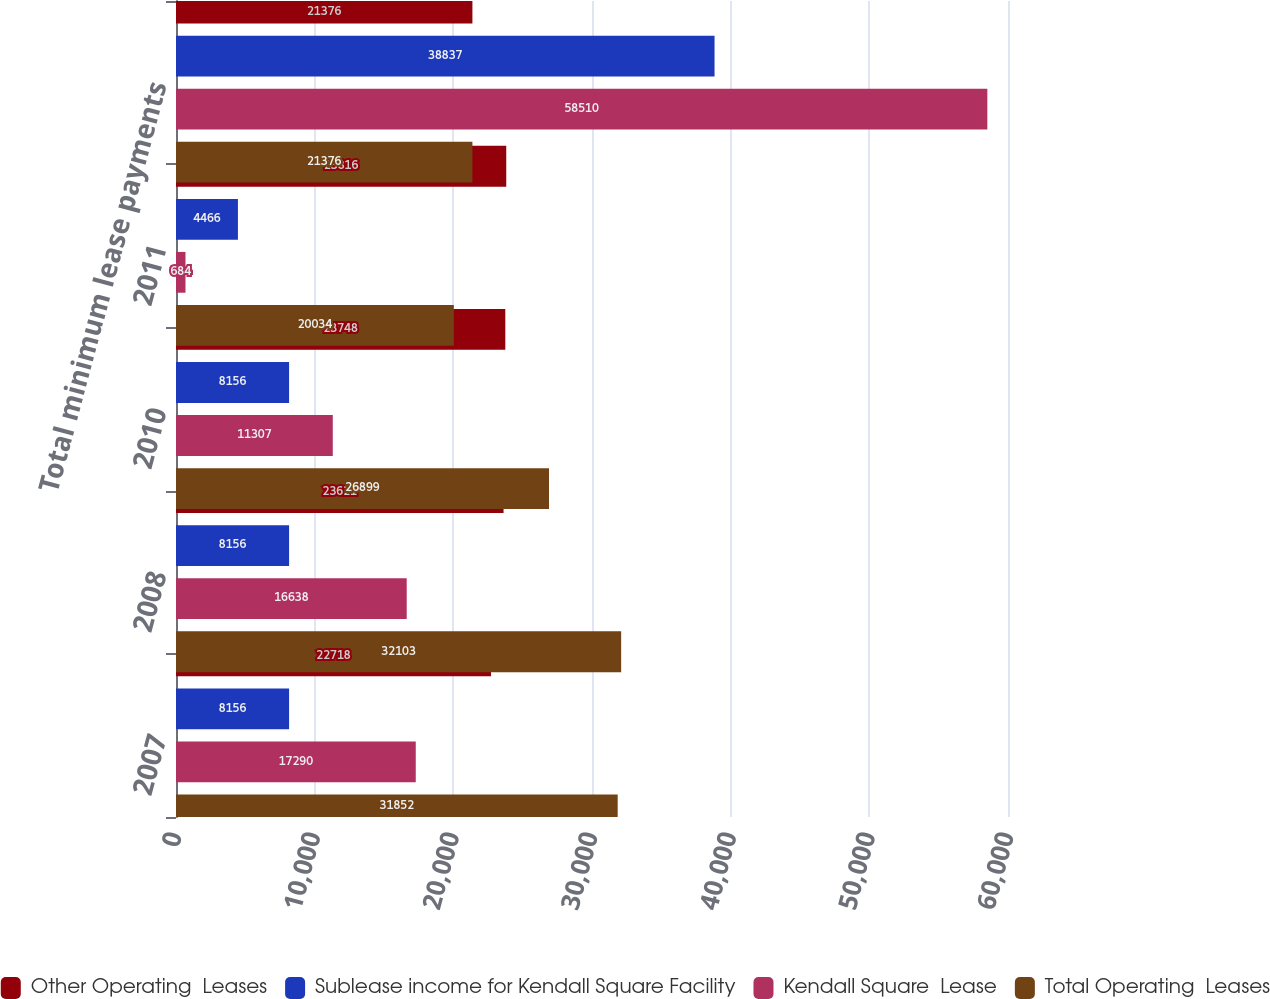Convert chart. <chart><loc_0><loc_0><loc_500><loc_500><stacked_bar_chart><ecel><fcel>2007<fcel>2008<fcel>2010<fcel>2011<fcel>Total minimum lease payments<nl><fcel>Other Operating  Leases<fcel>22718<fcel>23621<fcel>23748<fcel>23816<fcel>21376<nl><fcel>Sublease income for Kendall Square Facility<fcel>8156<fcel>8156<fcel>8156<fcel>4466<fcel>38837<nl><fcel>Kendall Square  Lease<fcel>17290<fcel>16638<fcel>11307<fcel>684<fcel>58510<nl><fcel>Total Operating  Leases<fcel>31852<fcel>32103<fcel>26899<fcel>20034<fcel>21376<nl></chart> 